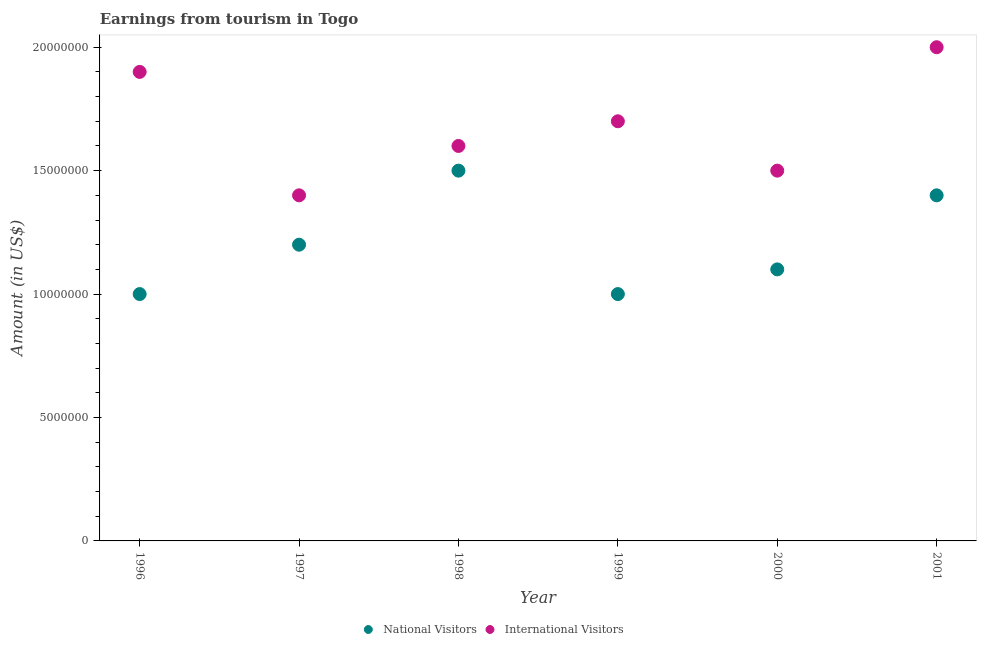How many different coloured dotlines are there?
Your response must be concise. 2. Is the number of dotlines equal to the number of legend labels?
Make the answer very short. Yes. What is the amount earned from national visitors in 1999?
Your response must be concise. 1.00e+07. Across all years, what is the maximum amount earned from international visitors?
Provide a short and direct response. 2.00e+07. Across all years, what is the minimum amount earned from international visitors?
Give a very brief answer. 1.40e+07. In which year was the amount earned from international visitors maximum?
Keep it short and to the point. 2001. In which year was the amount earned from international visitors minimum?
Your response must be concise. 1997. What is the total amount earned from national visitors in the graph?
Offer a terse response. 7.20e+07. What is the difference between the amount earned from national visitors in 1997 and that in 2000?
Keep it short and to the point. 1.00e+06. What is the difference between the amount earned from national visitors in 1999 and the amount earned from international visitors in 1998?
Offer a terse response. -6.00e+06. What is the average amount earned from international visitors per year?
Your answer should be very brief. 1.68e+07. In the year 2000, what is the difference between the amount earned from international visitors and amount earned from national visitors?
Provide a short and direct response. 4.00e+06. In how many years, is the amount earned from international visitors greater than 11000000 US$?
Your answer should be compact. 6. What is the ratio of the amount earned from national visitors in 1996 to that in 2000?
Ensure brevity in your answer.  0.91. What is the difference between the highest and the lowest amount earned from international visitors?
Make the answer very short. 6.00e+06. Does the amount earned from international visitors monotonically increase over the years?
Provide a succinct answer. No. Is the amount earned from international visitors strictly greater than the amount earned from national visitors over the years?
Keep it short and to the point. Yes. Is the amount earned from national visitors strictly less than the amount earned from international visitors over the years?
Your answer should be very brief. Yes. How many dotlines are there?
Keep it short and to the point. 2. How many years are there in the graph?
Your response must be concise. 6. What is the difference between two consecutive major ticks on the Y-axis?
Make the answer very short. 5.00e+06. Does the graph contain any zero values?
Keep it short and to the point. No. How many legend labels are there?
Provide a succinct answer. 2. What is the title of the graph?
Keep it short and to the point. Earnings from tourism in Togo. Does "Electricity and heat production" appear as one of the legend labels in the graph?
Offer a terse response. No. What is the label or title of the X-axis?
Give a very brief answer. Year. What is the label or title of the Y-axis?
Your answer should be compact. Amount (in US$). What is the Amount (in US$) in National Visitors in 1996?
Provide a succinct answer. 1.00e+07. What is the Amount (in US$) in International Visitors in 1996?
Provide a short and direct response. 1.90e+07. What is the Amount (in US$) of International Visitors in 1997?
Offer a terse response. 1.40e+07. What is the Amount (in US$) in National Visitors in 1998?
Ensure brevity in your answer.  1.50e+07. What is the Amount (in US$) of International Visitors in 1998?
Provide a succinct answer. 1.60e+07. What is the Amount (in US$) of National Visitors in 1999?
Make the answer very short. 1.00e+07. What is the Amount (in US$) of International Visitors in 1999?
Keep it short and to the point. 1.70e+07. What is the Amount (in US$) of National Visitors in 2000?
Your answer should be compact. 1.10e+07. What is the Amount (in US$) in International Visitors in 2000?
Your answer should be very brief. 1.50e+07. What is the Amount (in US$) of National Visitors in 2001?
Provide a succinct answer. 1.40e+07. What is the Amount (in US$) in International Visitors in 2001?
Offer a terse response. 2.00e+07. Across all years, what is the maximum Amount (in US$) of National Visitors?
Your response must be concise. 1.50e+07. Across all years, what is the maximum Amount (in US$) in International Visitors?
Your answer should be very brief. 2.00e+07. Across all years, what is the minimum Amount (in US$) of International Visitors?
Keep it short and to the point. 1.40e+07. What is the total Amount (in US$) of National Visitors in the graph?
Offer a very short reply. 7.20e+07. What is the total Amount (in US$) of International Visitors in the graph?
Your answer should be compact. 1.01e+08. What is the difference between the Amount (in US$) of National Visitors in 1996 and that in 1998?
Provide a succinct answer. -5.00e+06. What is the difference between the Amount (in US$) of International Visitors in 1996 and that in 1998?
Your answer should be compact. 3.00e+06. What is the difference between the Amount (in US$) of National Visitors in 1996 and that in 2000?
Offer a very short reply. -1.00e+06. What is the difference between the Amount (in US$) in International Visitors in 1996 and that in 2000?
Offer a terse response. 4.00e+06. What is the difference between the Amount (in US$) in National Visitors in 1996 and that in 2001?
Offer a terse response. -4.00e+06. What is the difference between the Amount (in US$) in National Visitors in 1997 and that in 1998?
Offer a terse response. -3.00e+06. What is the difference between the Amount (in US$) of International Visitors in 1997 and that in 1999?
Your answer should be very brief. -3.00e+06. What is the difference between the Amount (in US$) of National Visitors in 1997 and that in 2000?
Provide a short and direct response. 1.00e+06. What is the difference between the Amount (in US$) of National Visitors in 1997 and that in 2001?
Your answer should be very brief. -2.00e+06. What is the difference between the Amount (in US$) in International Visitors in 1997 and that in 2001?
Keep it short and to the point. -6.00e+06. What is the difference between the Amount (in US$) in International Visitors in 1998 and that in 1999?
Your answer should be very brief. -1.00e+06. What is the difference between the Amount (in US$) in International Visitors in 1998 and that in 2001?
Offer a terse response. -4.00e+06. What is the difference between the Amount (in US$) of National Visitors in 1999 and that in 2001?
Provide a short and direct response. -4.00e+06. What is the difference between the Amount (in US$) in International Visitors in 1999 and that in 2001?
Your answer should be very brief. -3.00e+06. What is the difference between the Amount (in US$) of International Visitors in 2000 and that in 2001?
Provide a short and direct response. -5.00e+06. What is the difference between the Amount (in US$) of National Visitors in 1996 and the Amount (in US$) of International Visitors in 1998?
Your answer should be compact. -6.00e+06. What is the difference between the Amount (in US$) in National Visitors in 1996 and the Amount (in US$) in International Visitors in 1999?
Ensure brevity in your answer.  -7.00e+06. What is the difference between the Amount (in US$) of National Visitors in 1996 and the Amount (in US$) of International Visitors in 2000?
Offer a very short reply. -5.00e+06. What is the difference between the Amount (in US$) in National Visitors in 1996 and the Amount (in US$) in International Visitors in 2001?
Your answer should be very brief. -1.00e+07. What is the difference between the Amount (in US$) of National Visitors in 1997 and the Amount (in US$) of International Visitors in 1998?
Make the answer very short. -4.00e+06. What is the difference between the Amount (in US$) in National Visitors in 1997 and the Amount (in US$) in International Visitors in 1999?
Offer a terse response. -5.00e+06. What is the difference between the Amount (in US$) of National Visitors in 1997 and the Amount (in US$) of International Visitors in 2000?
Your response must be concise. -3.00e+06. What is the difference between the Amount (in US$) of National Visitors in 1997 and the Amount (in US$) of International Visitors in 2001?
Offer a very short reply. -8.00e+06. What is the difference between the Amount (in US$) in National Visitors in 1998 and the Amount (in US$) in International Visitors in 2001?
Give a very brief answer. -5.00e+06. What is the difference between the Amount (in US$) of National Visitors in 1999 and the Amount (in US$) of International Visitors in 2000?
Keep it short and to the point. -5.00e+06. What is the difference between the Amount (in US$) in National Visitors in 1999 and the Amount (in US$) in International Visitors in 2001?
Offer a terse response. -1.00e+07. What is the difference between the Amount (in US$) of National Visitors in 2000 and the Amount (in US$) of International Visitors in 2001?
Keep it short and to the point. -9.00e+06. What is the average Amount (in US$) of International Visitors per year?
Give a very brief answer. 1.68e+07. In the year 1996, what is the difference between the Amount (in US$) in National Visitors and Amount (in US$) in International Visitors?
Offer a very short reply. -9.00e+06. In the year 1998, what is the difference between the Amount (in US$) of National Visitors and Amount (in US$) of International Visitors?
Offer a terse response. -1.00e+06. In the year 1999, what is the difference between the Amount (in US$) of National Visitors and Amount (in US$) of International Visitors?
Give a very brief answer. -7.00e+06. In the year 2000, what is the difference between the Amount (in US$) in National Visitors and Amount (in US$) in International Visitors?
Make the answer very short. -4.00e+06. In the year 2001, what is the difference between the Amount (in US$) in National Visitors and Amount (in US$) in International Visitors?
Give a very brief answer. -6.00e+06. What is the ratio of the Amount (in US$) of International Visitors in 1996 to that in 1997?
Provide a short and direct response. 1.36. What is the ratio of the Amount (in US$) in National Visitors in 1996 to that in 1998?
Your answer should be very brief. 0.67. What is the ratio of the Amount (in US$) of International Visitors in 1996 to that in 1998?
Your response must be concise. 1.19. What is the ratio of the Amount (in US$) in International Visitors in 1996 to that in 1999?
Your answer should be very brief. 1.12. What is the ratio of the Amount (in US$) in International Visitors in 1996 to that in 2000?
Ensure brevity in your answer.  1.27. What is the ratio of the Amount (in US$) of International Visitors in 1996 to that in 2001?
Make the answer very short. 0.95. What is the ratio of the Amount (in US$) in National Visitors in 1997 to that in 1998?
Give a very brief answer. 0.8. What is the ratio of the Amount (in US$) in International Visitors in 1997 to that in 1998?
Offer a very short reply. 0.88. What is the ratio of the Amount (in US$) in National Visitors in 1997 to that in 1999?
Provide a short and direct response. 1.2. What is the ratio of the Amount (in US$) in International Visitors in 1997 to that in 1999?
Ensure brevity in your answer.  0.82. What is the ratio of the Amount (in US$) of National Visitors in 1997 to that in 2001?
Your answer should be very brief. 0.86. What is the ratio of the Amount (in US$) of National Visitors in 1998 to that in 2000?
Your answer should be very brief. 1.36. What is the ratio of the Amount (in US$) of International Visitors in 1998 to that in 2000?
Your response must be concise. 1.07. What is the ratio of the Amount (in US$) in National Visitors in 1998 to that in 2001?
Make the answer very short. 1.07. What is the ratio of the Amount (in US$) of International Visitors in 1998 to that in 2001?
Keep it short and to the point. 0.8. What is the ratio of the Amount (in US$) of National Visitors in 1999 to that in 2000?
Keep it short and to the point. 0.91. What is the ratio of the Amount (in US$) of International Visitors in 1999 to that in 2000?
Your answer should be compact. 1.13. What is the ratio of the Amount (in US$) of National Visitors in 2000 to that in 2001?
Offer a terse response. 0.79. What is the difference between the highest and the lowest Amount (in US$) in International Visitors?
Offer a terse response. 6.00e+06. 